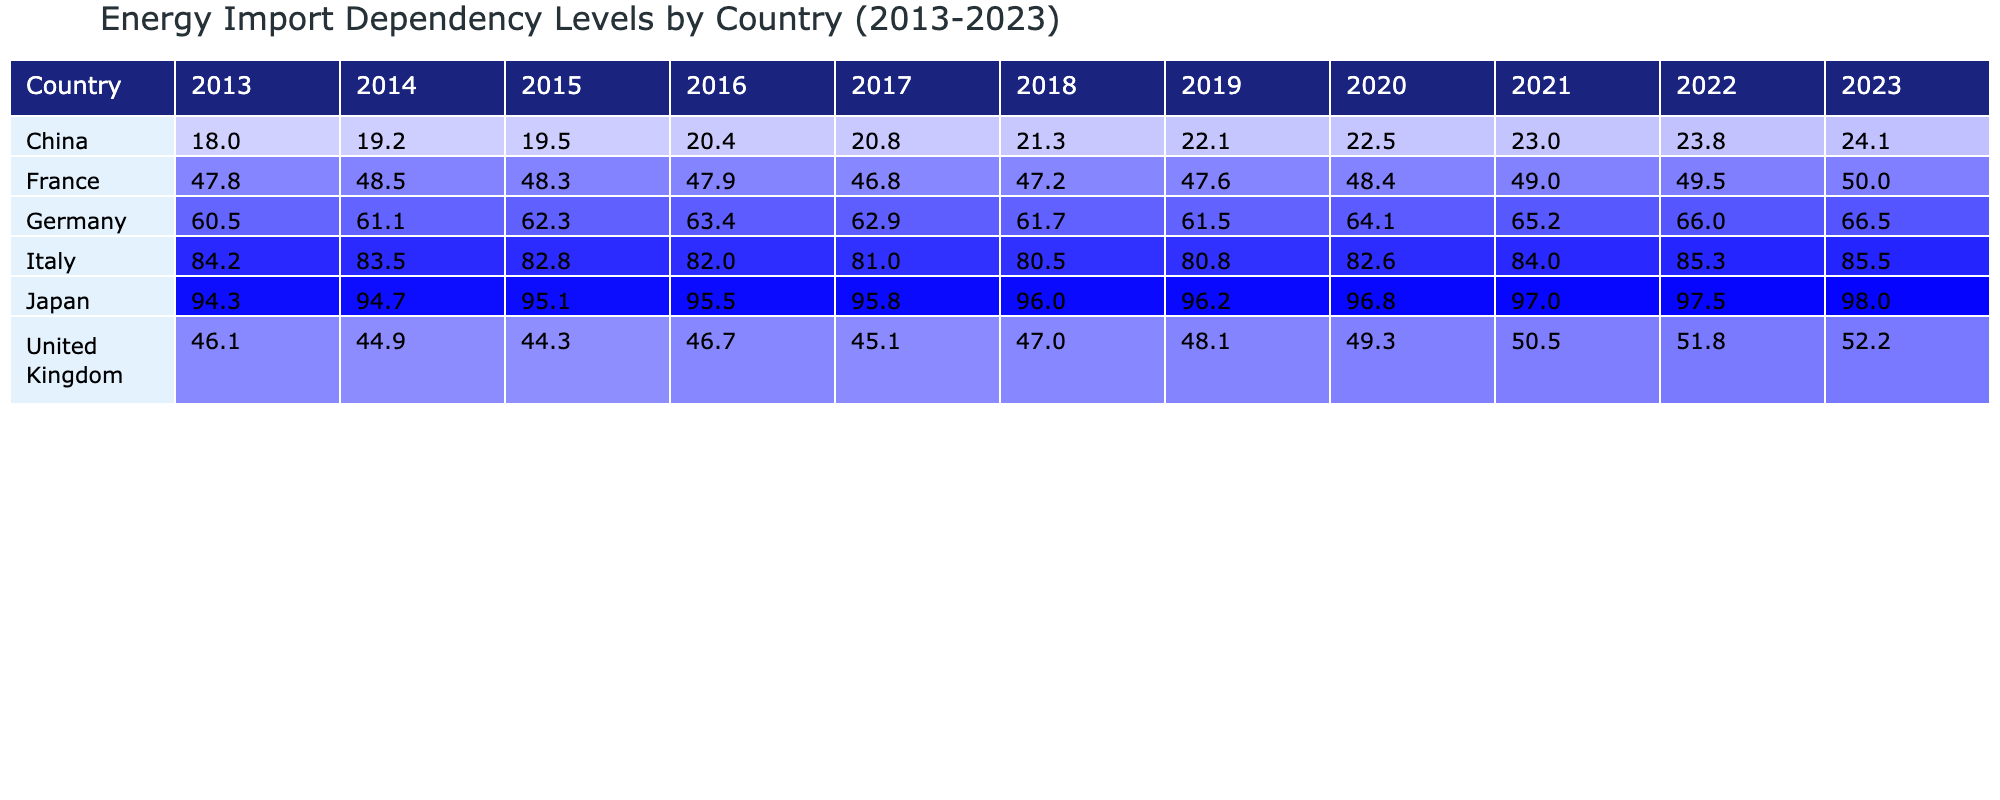What was the energy import dependency percentage of Germany in 2020? According to the table, Germany's energy import dependency in 2020 is explicitly stated as 64.1%.
Answer: 64.1% Which country had the highest energy import dependency level in 2023? The table shows that Japan had the highest energy import dependency level in 2023 at 98.0%.
Answer: Japan What was the difference between Italy's energy import dependency in 2013 and 2023? Italy's energy import dependency in 2013 was 84.2%, and in 2023 it was 85.5%. The difference is calculated as 85.5% - 84.2% = 1.3%.
Answer: 1.3% Has France's energy import dependency increased every year from 2013 to 2023? By examining the table, it is clear that France's energy import dependency fluctuated slightly and did not consistently increase, as it decreased from 48.5% in 2014 to 46.8% in 2017.
Answer: No What was the average energy import dependency for the United Kingdom from 2013 to 2023? To find the average, add the percentages: 46.1 + 44.9 + 44.3 + 46.7 + 45.1 + 47.0 + 48.1 + 49.3 + 51.8 + 52.2 = 466.5. There are 11 data points, so the average is 466.5 / 11 = 42.23.
Answer: 46.65 Which country shows a trend of decreasing energy import dependency over the years? Looking at the data, both Germany and Italy exhibit a general trend in their energy import dependency but they do not show a clear decreasing trend; Italy inconsistent while Germany shows a gradual increase.
Answer: None In which year did China’s energy import dependency exceed 20% for the first time? The table indicates that China’s energy import dependency crossed 20% for the first time in 2016, where it was 20.4%.
Answer: 2016 What percentage increase did Japan's energy import dependency experience from 2013 to 2023? Japan's energy import dependency was 94.3% in 2013 and rose to 98.0% in 2023. The increase is calculated as 98.0% - 94.3% = 3.7%.
Answer: 3.7% Are there any countries whose energy import dependency was below 50% in 2023? From the table, the only country with an energy import dependency below 50% in 2023 is France at 50.0%.
Answer: Yes What was Germany's energy import dependency level in relation to Japan's in 2022? In the table, Germany had an energy import dependency of 66.0%, whereas Japan had 97.5% in 2022. The difference shows Germany had a significantly lower percentage than Japan.
Answer: Lower 